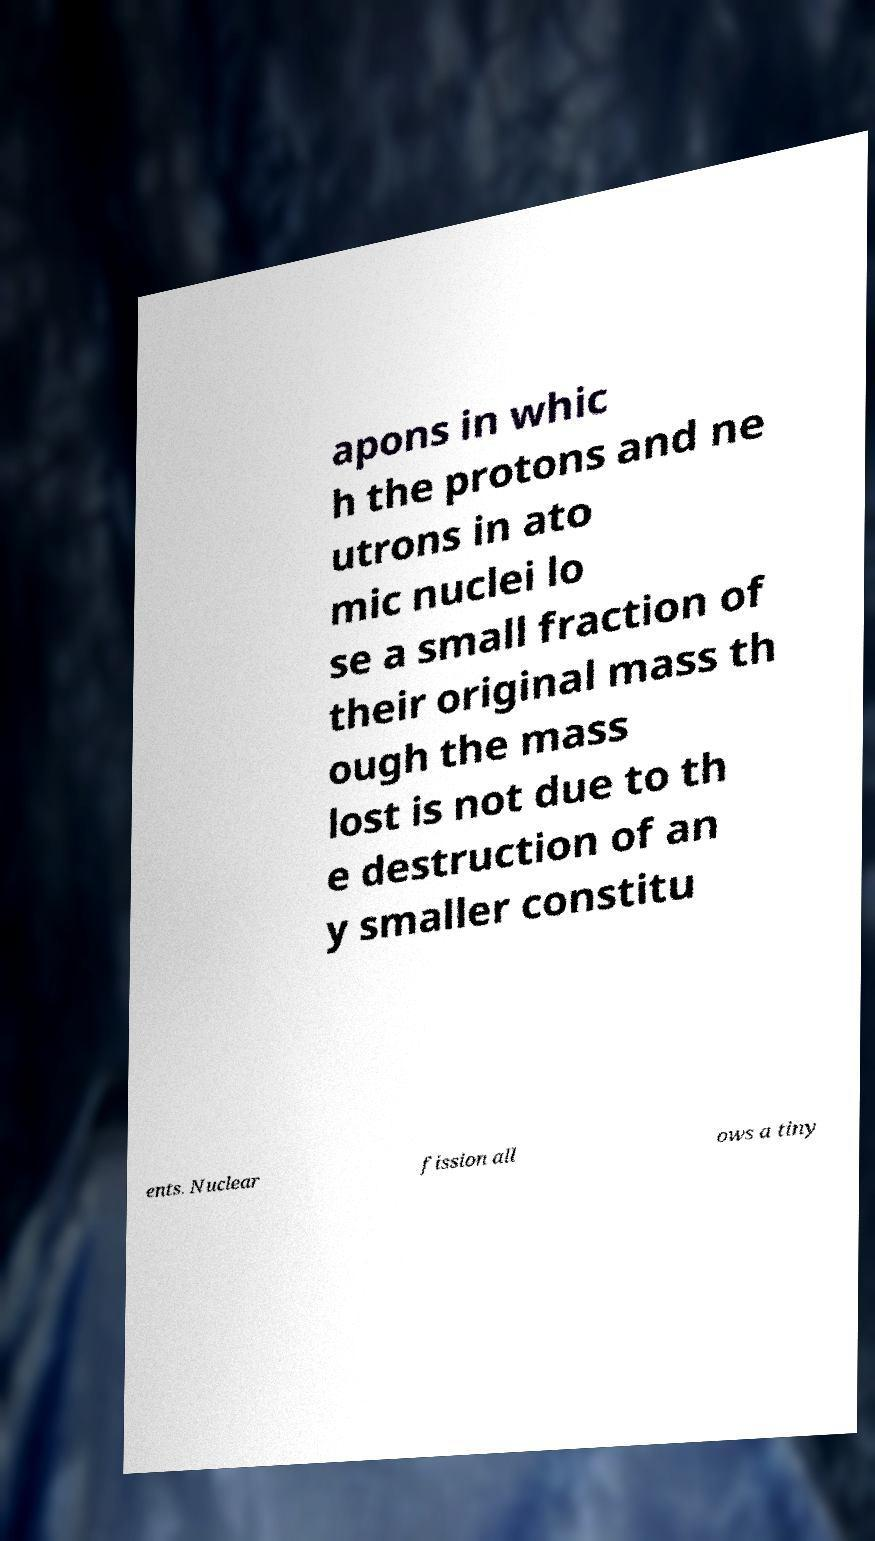Could you extract and type out the text from this image? apons in whic h the protons and ne utrons in ato mic nuclei lo se a small fraction of their original mass th ough the mass lost is not due to th e destruction of an y smaller constitu ents. Nuclear fission all ows a tiny 